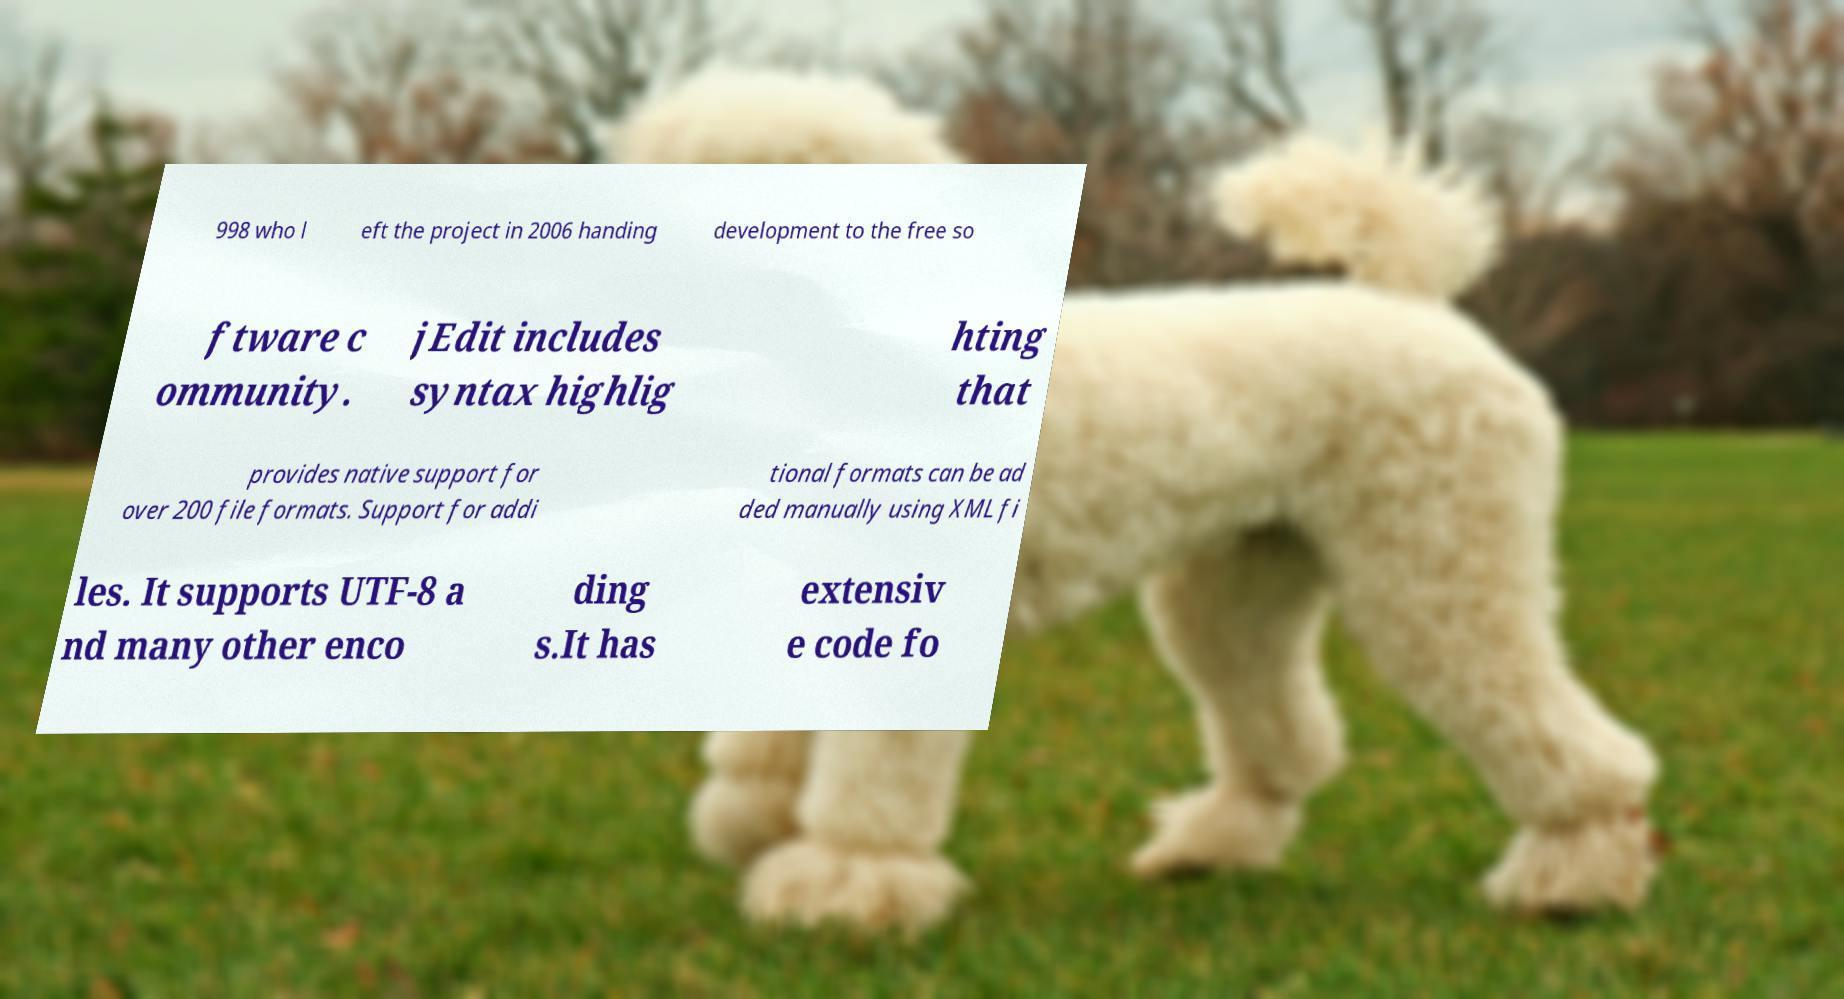I need the written content from this picture converted into text. Can you do that? 998 who l eft the project in 2006 handing development to the free so ftware c ommunity. jEdit includes syntax highlig hting that provides native support for over 200 file formats. Support for addi tional formats can be ad ded manually using XML fi les. It supports UTF-8 a nd many other enco ding s.It has extensiv e code fo 